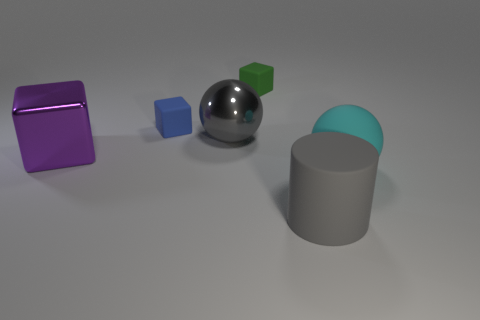Add 2 big gray shiny spheres. How many objects exist? 8 Subtract all balls. How many objects are left? 4 Subtract all blue rubber cubes. Subtract all blue cubes. How many objects are left? 4 Add 3 small green matte things. How many small green matte things are left? 4 Add 3 large cyan things. How many large cyan things exist? 4 Subtract 1 gray cylinders. How many objects are left? 5 